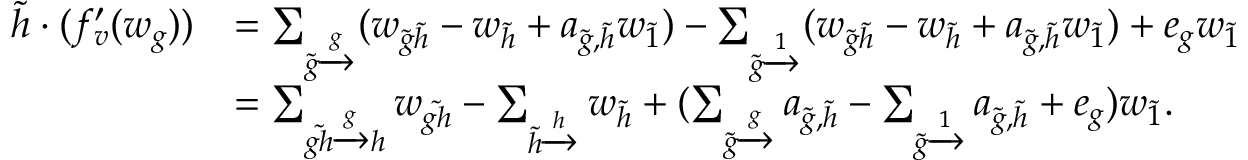<formula> <loc_0><loc_0><loc_500><loc_500>\begin{array} { r l } { \tilde { h } \cdot ( f _ { v } ^ { \prime } ( w _ { g } ) ) } & { = \sum _ { \tilde { g } \xrightarrow [ ] g } ( w _ { \tilde { g } \tilde { h } } - w _ { \tilde { h } } + a _ { \tilde { g } , \tilde { h } } w _ { \tilde { 1 } } ) - \sum _ { \tilde { g } \xrightarrow [ ] 1 } ( w _ { \tilde { g } \tilde { h } } - w _ { \tilde { h } } + a _ { \tilde { g } , \tilde { h } } w _ { \tilde { 1 } } ) + e _ { g } w _ { \tilde { 1 } } } \\ & { = \sum _ { \tilde { g h } \xrightarrow [ ] g h } w _ { \tilde { g h } } - \sum _ { \tilde { h } \xrightarrow [ ] h } w _ { \tilde { h } } + ( \sum _ { \tilde { g } \xrightarrow [ ] g } a _ { \tilde { g } , \tilde { h } } - \sum _ { \tilde { g } \xrightarrow [ ] 1 } a _ { \tilde { g } , \tilde { h } } + e _ { g } ) w _ { \tilde { 1 } } . } \end{array}</formula> 